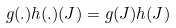Convert formula to latex. <formula><loc_0><loc_0><loc_500><loc_500>g ( . ) h ( . ) ( J ) = g ( J ) h ( J )</formula> 